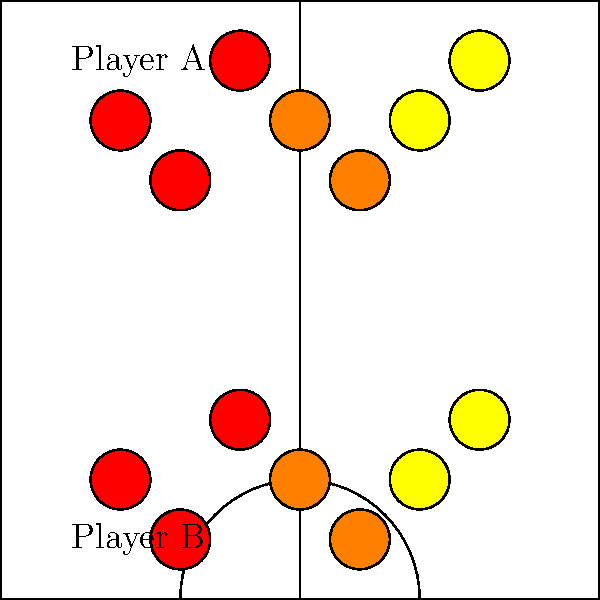Based on the heat maps shown for Player A and Player B, which player is more likely to be a Point Guard, and which is more likely to be a Center? To determine the likely positions of Player A and Player B based on their heat maps, we need to analyze their gameplay patterns:

1. Player A's heat map:
   - Concentrated activity in the top half of the court
   - High intensity (red and orange) around the three-point line and top of the key
   - Some activity (yellow) extending towards the wing areas

2. Player B's heat map:
   - Concentrated activity in the bottom half of the court
   - High intensity (red and orange) near the basket and in the low post area
   - Some activity (yellow) extending slightly outward from the paint

3. Characteristics of a Point Guard:
   - Typically operates around the perimeter
   - Often initiates plays from the top of the key
   - Involved in ball handling and distributing

4. Characteristics of a Center:
   - Primarily operates near the basket and in the low post
   - Focuses on scoring close to the hoop and rebounding
   - Less active in perimeter play

5. Comparison:
   - Player A's heat map aligns with Point Guard characteristics
   - Player B's heat map aligns with Center characteristics

Therefore, Player A is more likely to be a Point Guard, while Player B is more likely to be a Center.
Answer: Player A: Point Guard; Player B: Center 